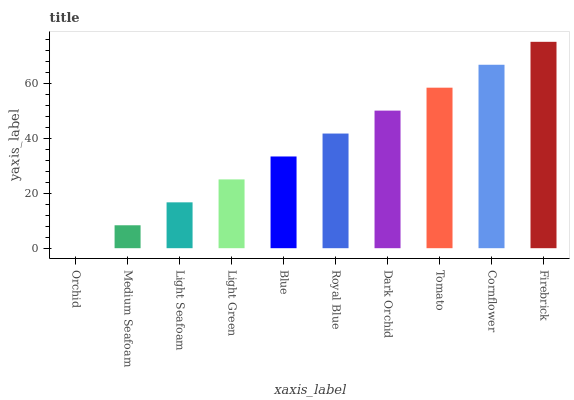Is Orchid the minimum?
Answer yes or no. Yes. Is Firebrick the maximum?
Answer yes or no. Yes. Is Medium Seafoam the minimum?
Answer yes or no. No. Is Medium Seafoam the maximum?
Answer yes or no. No. Is Medium Seafoam greater than Orchid?
Answer yes or no. Yes. Is Orchid less than Medium Seafoam?
Answer yes or no. Yes. Is Orchid greater than Medium Seafoam?
Answer yes or no. No. Is Medium Seafoam less than Orchid?
Answer yes or no. No. Is Royal Blue the high median?
Answer yes or no. Yes. Is Blue the low median?
Answer yes or no. Yes. Is Tomato the high median?
Answer yes or no. No. Is Light Seafoam the low median?
Answer yes or no. No. 